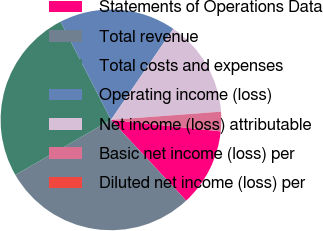Convert chart to OTSL. <chart><loc_0><loc_0><loc_500><loc_500><pie_chart><fcel>Statements of Operations Data<fcel>Total revenue<fcel>Total costs and expenses<fcel>Operating income (loss)<fcel>Net income (loss) attributable<fcel>Basic net income (loss) per<fcel>Diluted net income (loss) per<nl><fcel>11.41%<fcel>28.61%<fcel>25.76%<fcel>17.11%<fcel>14.26%<fcel>2.85%<fcel>0.0%<nl></chart> 